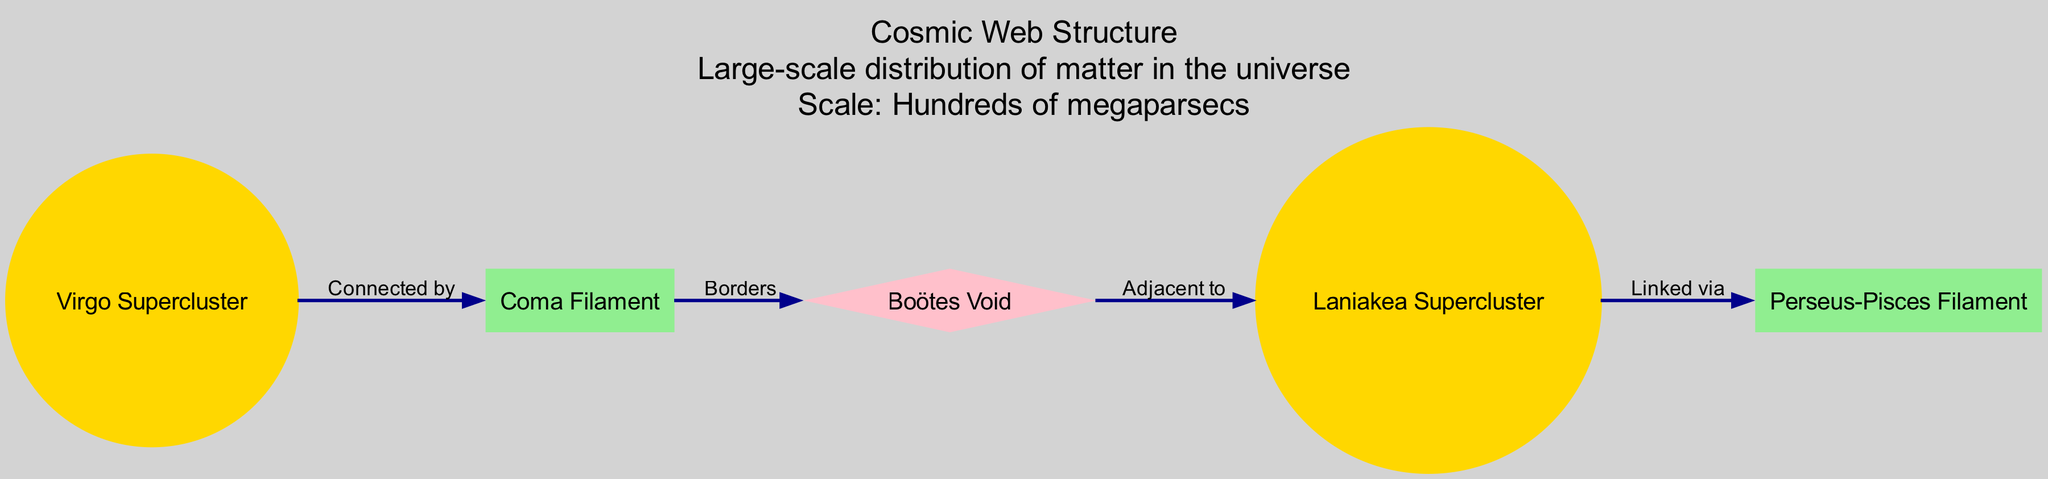What is the total number of nodes in the cosmic web diagram? The diagram lists five nodes representing various structures: Virgo Supercluster, Coma Filament, Boötes Void, Laniakea Supercluster, and Perseus-Pisces Filament. Counting these gives a total of five nodes.
Answer: 5 Which node is labeled as a Void? In the diagram, the node labeled "Boötes Void" is specifically categorized as a Void. This can be confirmed by looking for the node type that matches "Void."
Answer: Boötes Void How many edges connect the nodes in the cosmic web diagram? The diagram features four edges connecting the listed nodes: one from Virgo Supercluster to Coma Filament, one from Coma Filament to Boötes Void, one from Boötes Void to Laniakea Supercluster, and one from Laniakea Supercluster to Perseus-Pisces Filament. Therefore, there are four edges.
Answer: 4 What is the relationship between Virgo Supercluster and Coma Filament? According to the diagram, Virgo Supercluster is "Connected by" to Coma Filament, indicating a direct association between these two structures. This relationship is explicitly labeled along the edge connecting them.
Answer: Connected by Which two nodes have a relationship labeled as "Borders"? The nodes Coma Filament and Boötes Void share a relationship defined as "Borders." This can be found on the edge connecting these two nodes in the diagram.
Answer: Coma Filament and Boötes Void What type of structure is Perseus-Pisces? In the diagram, the Perseus-Pisces is identified as a Filament, which can be determined by checking the node's type designation.
Answer: Filament Which galaxy cluster is linked to the Perseus-Pisces Filament? The Laniakea Supercluster is the galaxy cluster linked to the Perseus-Pisces Filament, based on the connection defined as "Linked via" in the diagram.
Answer: Laniakea Supercluster What is the color used for galaxy clusters in the diagram? Galaxy clusters are represented in gold color within the diagram, differentiating them from filaments and voids. This can be seen by observing the color coding for each type of node.
Answer: Gold What is the title of this cosmic web structure diagram? The title of the diagram is "Cosmic Web Structure," which can be found at the top of the visual representation.
Answer: Cosmic Web Structure How is the Boötes Void positioned relative to Laniakea Supercluster? The Boötes Void is described as "Adjacent to" the Laniakea Supercluster in the diagram. This indicates they are next to each other in the cosmic web layout, indicating proximity without direct connection.
Answer: Adjacent to 